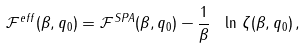Convert formula to latex. <formula><loc_0><loc_0><loc_500><loc_500>\mathcal { F } ^ { e f f } ( \beta , q _ { 0 } ) = \mathcal { F } ^ { S P A } ( \beta , q _ { 0 } ) - \frac { 1 } { \beta } \ \ln \, \zeta ( \beta , q _ { 0 } ) \, ,</formula> 